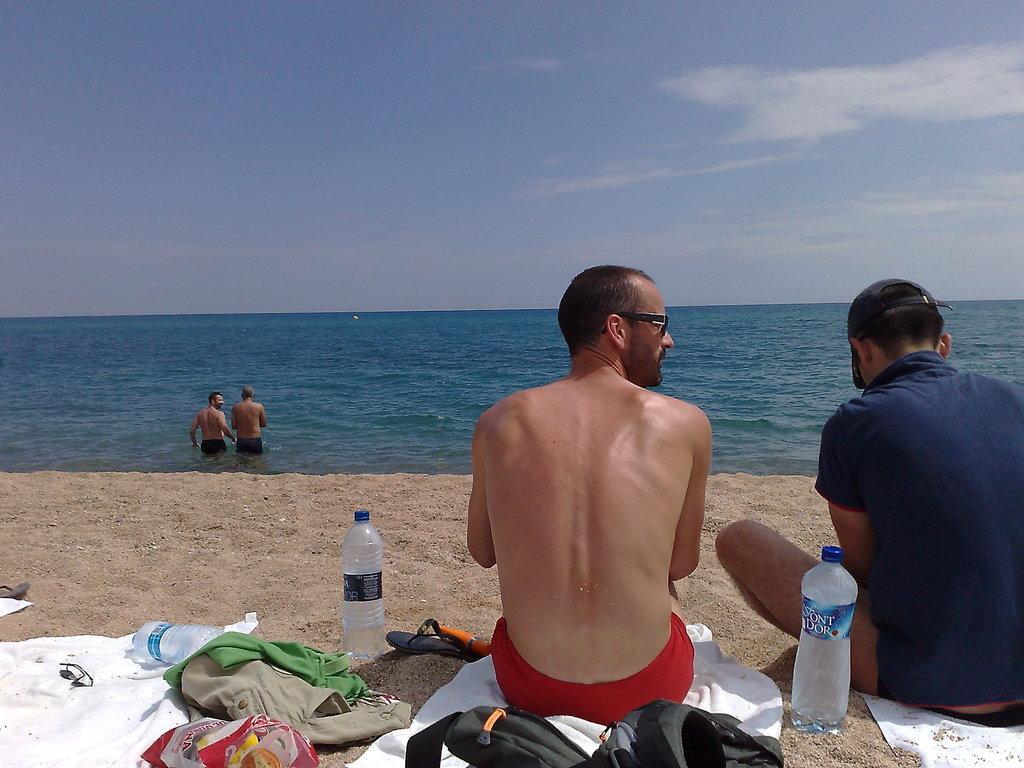How would you summarize this image in a sentence or two? This is a freshwater river. Persons are in water. These two persons are sitting on cloth. On this sand there is a cloth, bottle and bags. 